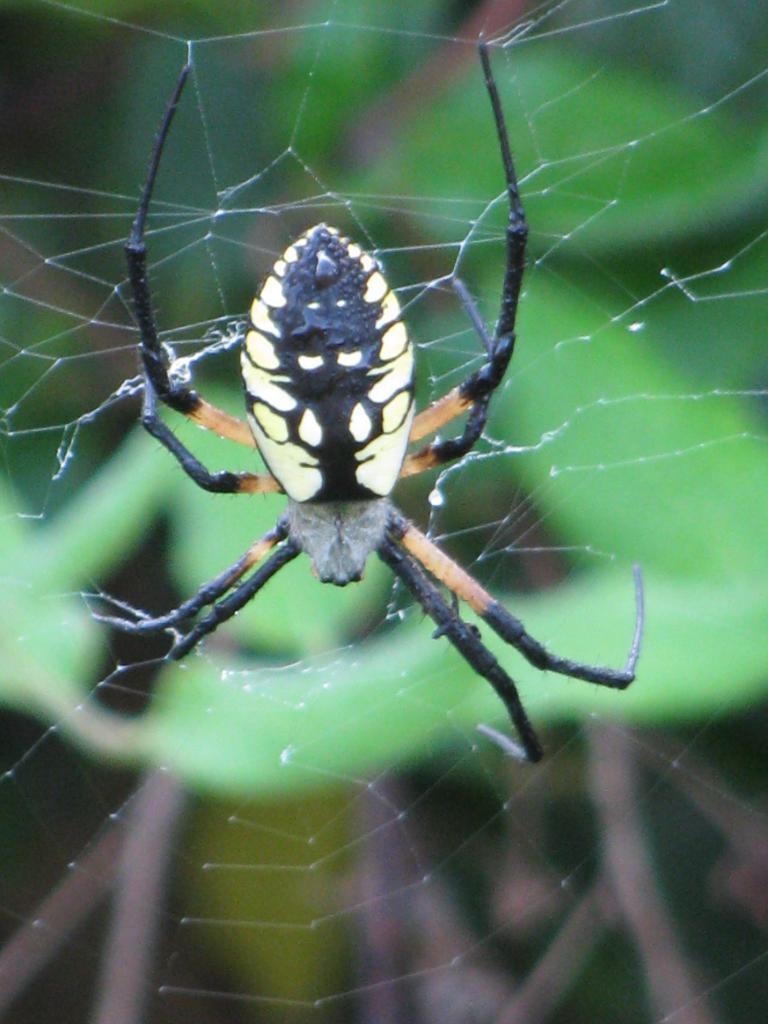Can you describe this image briefly? In the image we can see spider and spider net. 